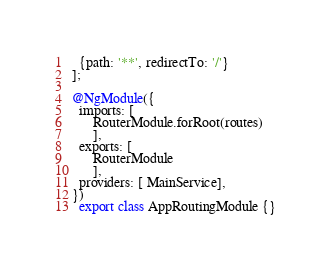<code> <loc_0><loc_0><loc_500><loc_500><_TypeScript_>  {path: '**', redirectTo: '/'} 
];

@NgModule({
  imports: [
      RouterModule.forRoot(routes)
      ],
  exports: [
      RouterModule
      ],
  providers: [ MainService],
})
  export class AppRoutingModule {}
</code> 